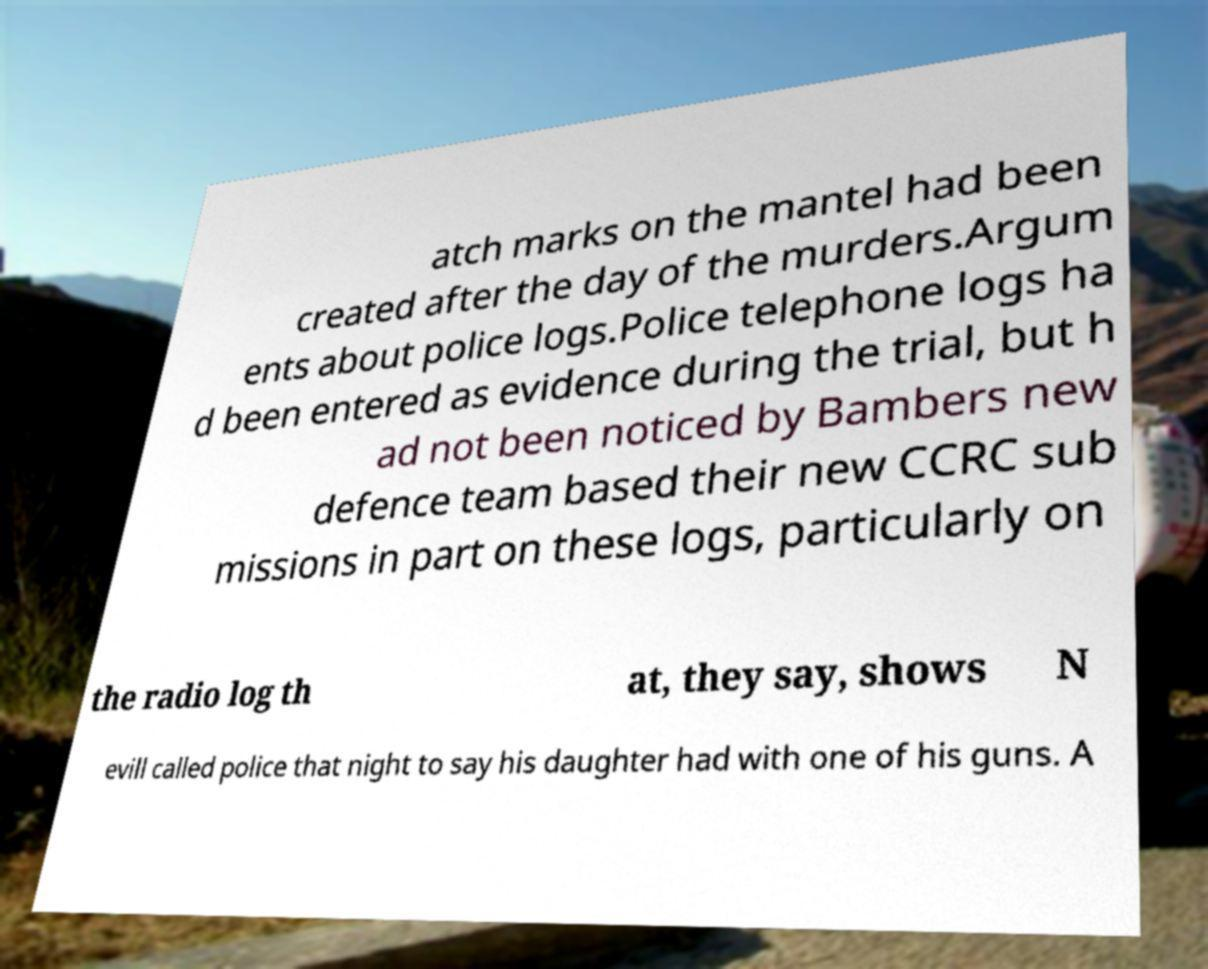I need the written content from this picture converted into text. Can you do that? atch marks on the mantel had been created after the day of the murders.Argum ents about police logs.Police telephone logs ha d been entered as evidence during the trial, but h ad not been noticed by Bambers new defence team based their new CCRC sub missions in part on these logs, particularly on the radio log th at, they say, shows N evill called police that night to say his daughter had with one of his guns. A 